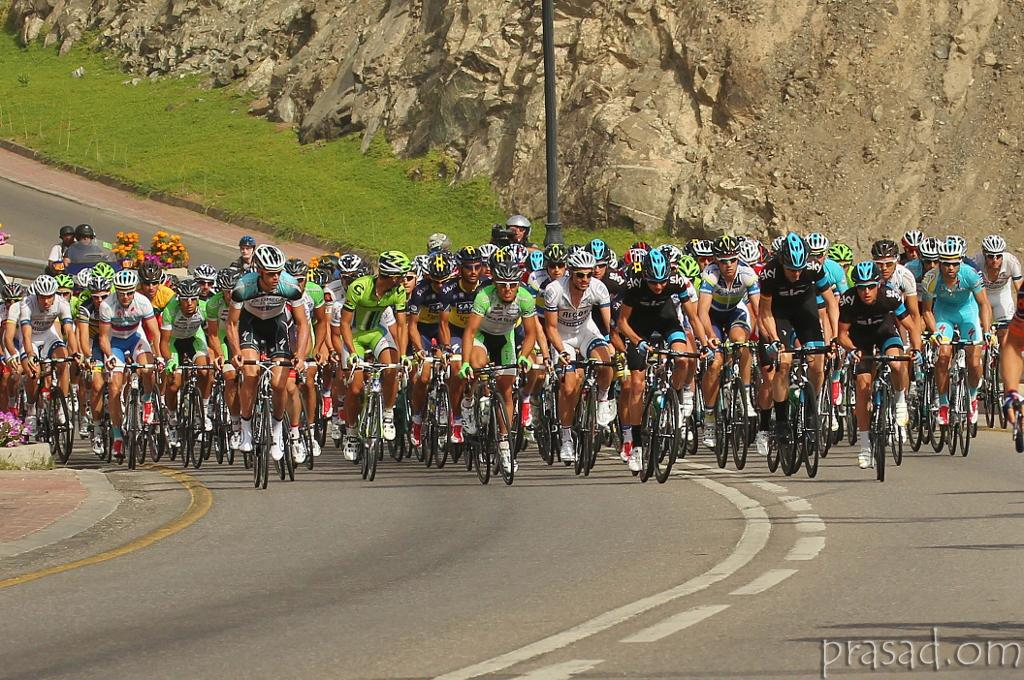What are the people in the image wearing on their heads and faces? The people in the image are wearing helmets and goggles. What activity are the people engaged in? The people are riding bikes on the road. What can be seen in the background of the image? There is a rock, a grass lawn, and a pole in the background of the image. What time of day is it in the image, and can you see a gate? The time of day is not mentioned in the image, and there is no gate present. Is there a rat visible in the image? No, there is no rat visible in the image. 